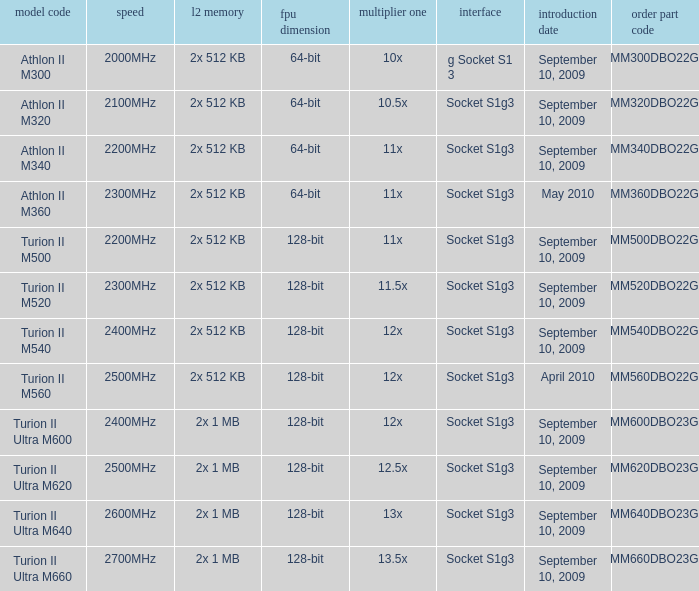What is the socket with an order part number of amm300dbo22gq and a September 10, 2009 release date? G socket s1 3. 